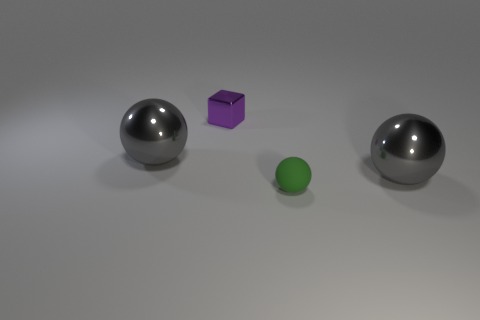Is the number of balls that are behind the small purple metallic object the same as the number of small green shiny cylinders?
Your response must be concise. Yes. Is there any other thing that has the same size as the rubber ball?
Provide a short and direct response. Yes. There is a big gray thing to the right of the tiny purple shiny object that is on the left side of the small matte sphere; what shape is it?
Provide a short and direct response. Sphere. Is the material of the large gray sphere to the right of the rubber thing the same as the small purple block?
Provide a short and direct response. Yes. Are there the same number of cubes to the right of the small green object and rubber objects behind the tiny purple block?
Provide a succinct answer. Yes. There is a large object right of the cube; what number of small metal things are in front of it?
Ensure brevity in your answer.  0. There is a big metallic object to the left of the tiny green object; does it have the same color as the big ball that is right of the tiny metallic block?
Your answer should be very brief. Yes. There is a sphere that is the same size as the shiny block; what is its material?
Offer a terse response. Rubber. What shape is the object behind the large metallic ball that is on the left side of the large thing that is right of the small purple metal block?
Provide a succinct answer. Cube. There is a green object that is the same size as the shiny block; what is its shape?
Ensure brevity in your answer.  Sphere. 